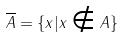<formula> <loc_0><loc_0><loc_500><loc_500>\overline { A } = \{ x | x \notin A \}</formula> 